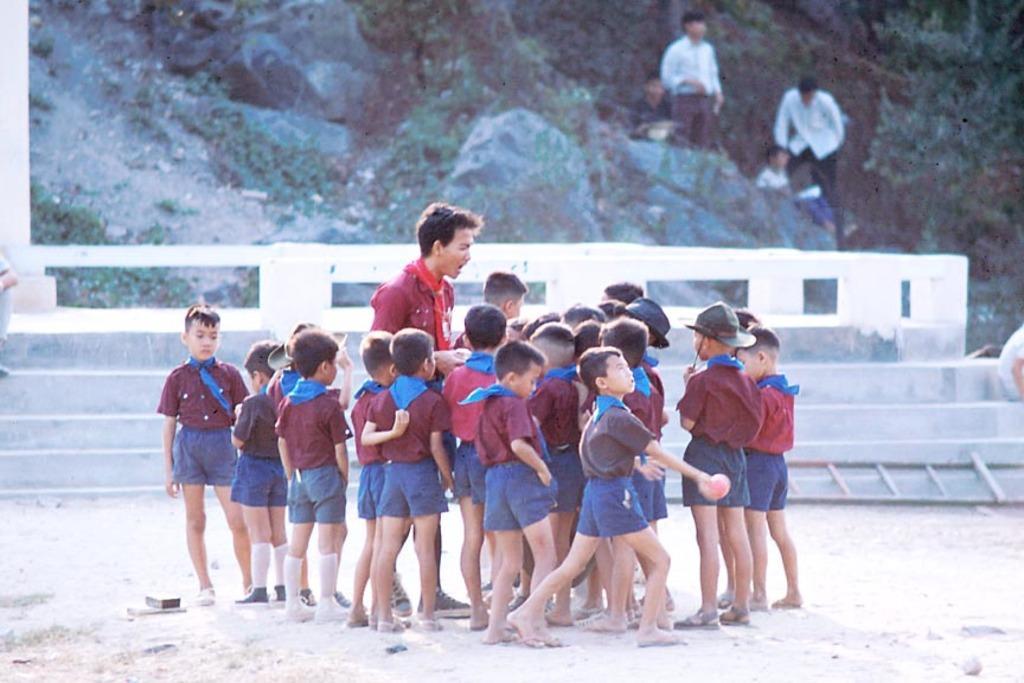In one or two sentences, can you explain what this image depicts? In this image we can see a few people, among them some are standing on the ground and some are on the mountains, also we can see a staircase and some trees. 